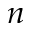Convert formula to latex. <formula><loc_0><loc_0><loc_500><loc_500>n</formula> 